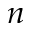Convert formula to latex. <formula><loc_0><loc_0><loc_500><loc_500>n</formula> 